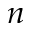Convert formula to latex. <formula><loc_0><loc_0><loc_500><loc_500>n</formula> 